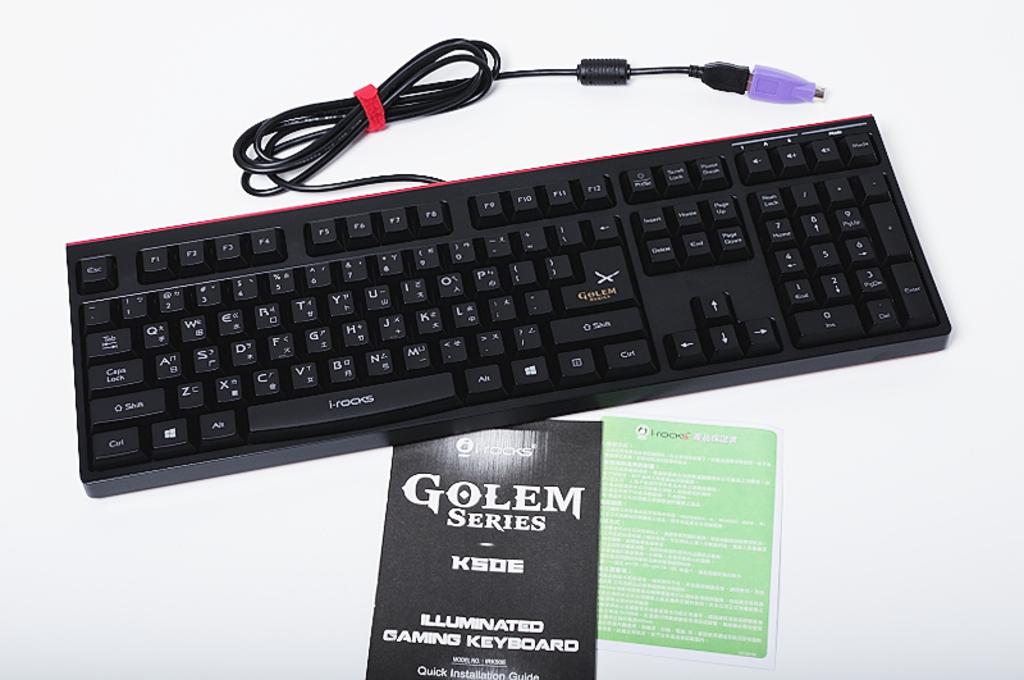Is this keyboard illuminated?
Your answer should be very brief. Yes. What series of keyboards is pictured here?
Your answer should be very brief. Golem. 